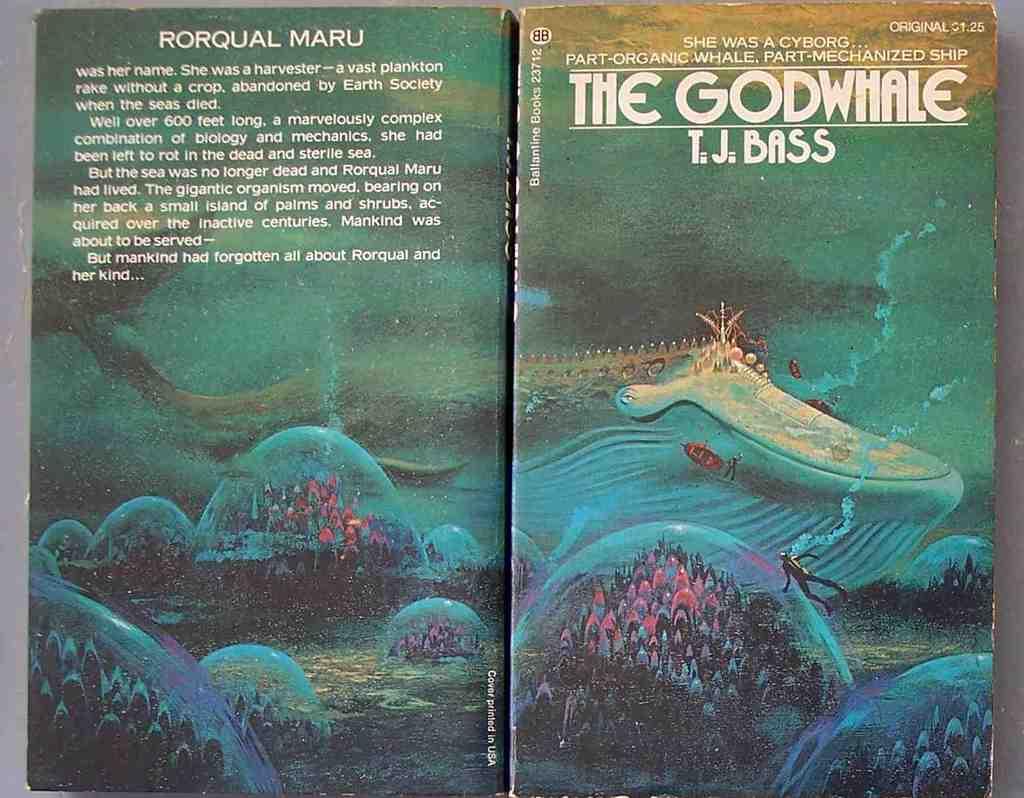What is the name of the main character in the book?
Make the answer very short. Rorqual maru. Who authored the book?
Make the answer very short. T.j. bass. 